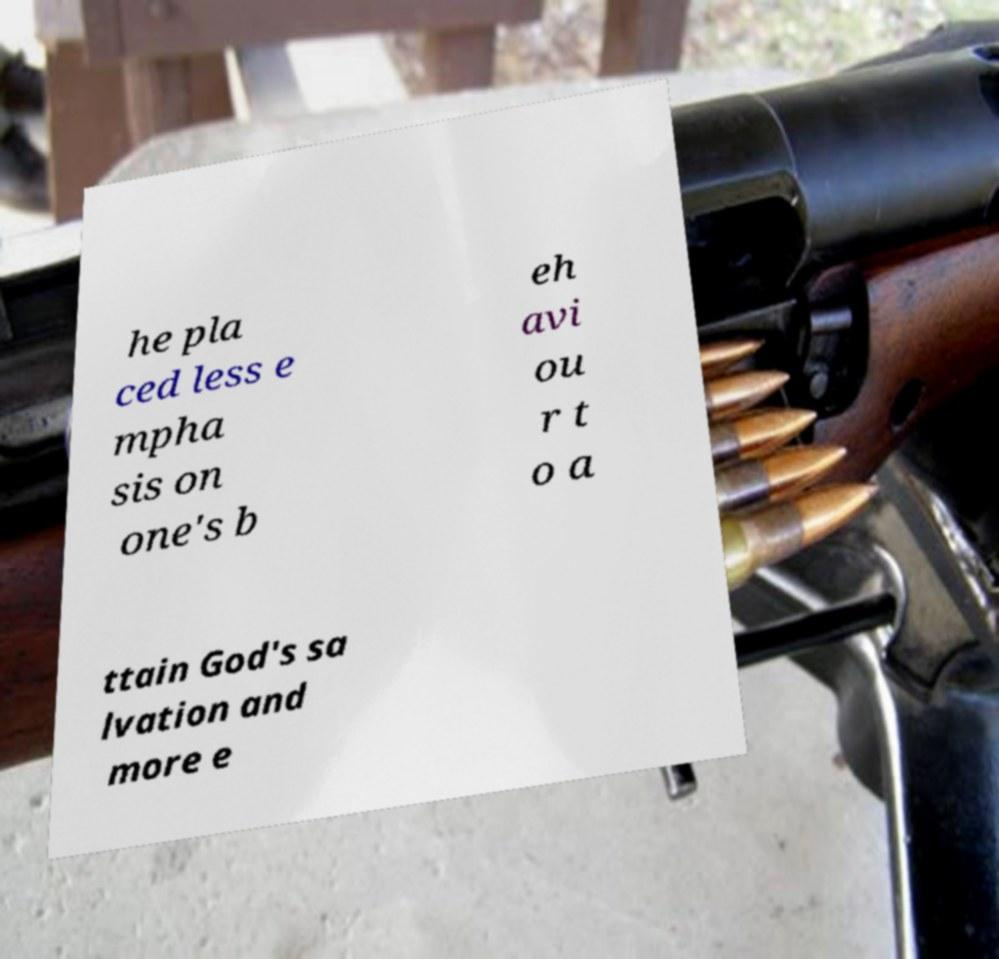Could you assist in decoding the text presented in this image and type it out clearly? he pla ced less e mpha sis on one's b eh avi ou r t o a ttain God's sa lvation and more e 